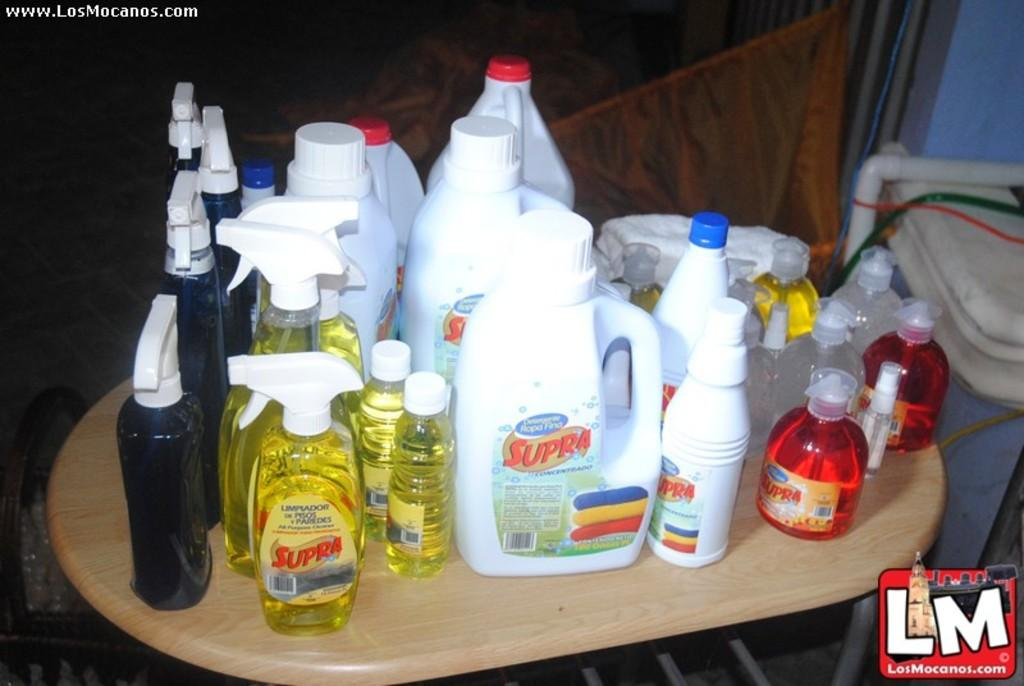<image>
Write a terse but informative summary of the picture. Various bottles of cleaners with the brand name Supra are shown together. 